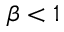<formula> <loc_0><loc_0><loc_500><loc_500>\beta < 1</formula> 